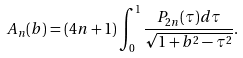<formula> <loc_0><loc_0><loc_500><loc_500>A _ { n } ( b ) = ( 4 n + 1 ) \int _ { 0 } ^ { 1 } \frac { P _ { 2 n } ( \tau ) d \tau } { \sqrt { 1 + b ^ { 2 } - \tau ^ { 2 } } } .</formula> 